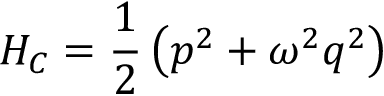<formula> <loc_0><loc_0><loc_500><loc_500>H _ { C } = \frac { 1 } { 2 } \left ( p ^ { 2 } + \omega ^ { 2 } q ^ { 2 } \right )</formula> 